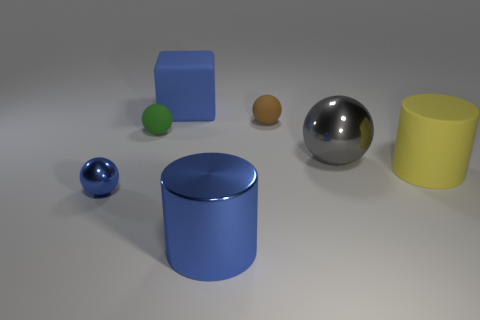Subtract all brown spheres. How many spheres are left? 3 Subtract all cylinders. How many objects are left? 5 Subtract 2 cylinders. How many cylinders are left? 0 Subtract all gray balls. Subtract all red cylinders. How many balls are left? 3 Subtract all brown spheres. How many blue cylinders are left? 1 Subtract all small green matte spheres. Subtract all matte objects. How many objects are left? 2 Add 5 big blue cylinders. How many big blue cylinders are left? 6 Add 7 small balls. How many small balls exist? 10 Add 1 gray balls. How many objects exist? 8 Subtract all blue spheres. How many spheres are left? 3 